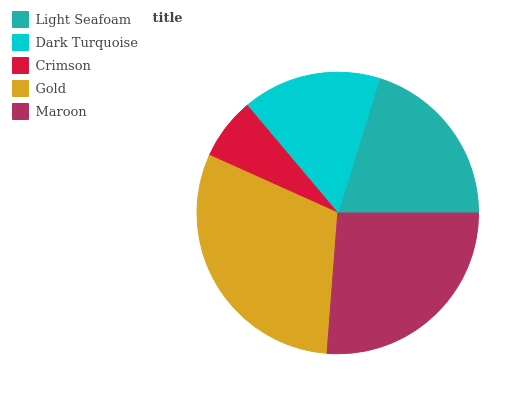Is Crimson the minimum?
Answer yes or no. Yes. Is Gold the maximum?
Answer yes or no. Yes. Is Dark Turquoise the minimum?
Answer yes or no. No. Is Dark Turquoise the maximum?
Answer yes or no. No. Is Light Seafoam greater than Dark Turquoise?
Answer yes or no. Yes. Is Dark Turquoise less than Light Seafoam?
Answer yes or no. Yes. Is Dark Turquoise greater than Light Seafoam?
Answer yes or no. No. Is Light Seafoam less than Dark Turquoise?
Answer yes or no. No. Is Light Seafoam the high median?
Answer yes or no. Yes. Is Light Seafoam the low median?
Answer yes or no. Yes. Is Crimson the high median?
Answer yes or no. No. Is Crimson the low median?
Answer yes or no. No. 